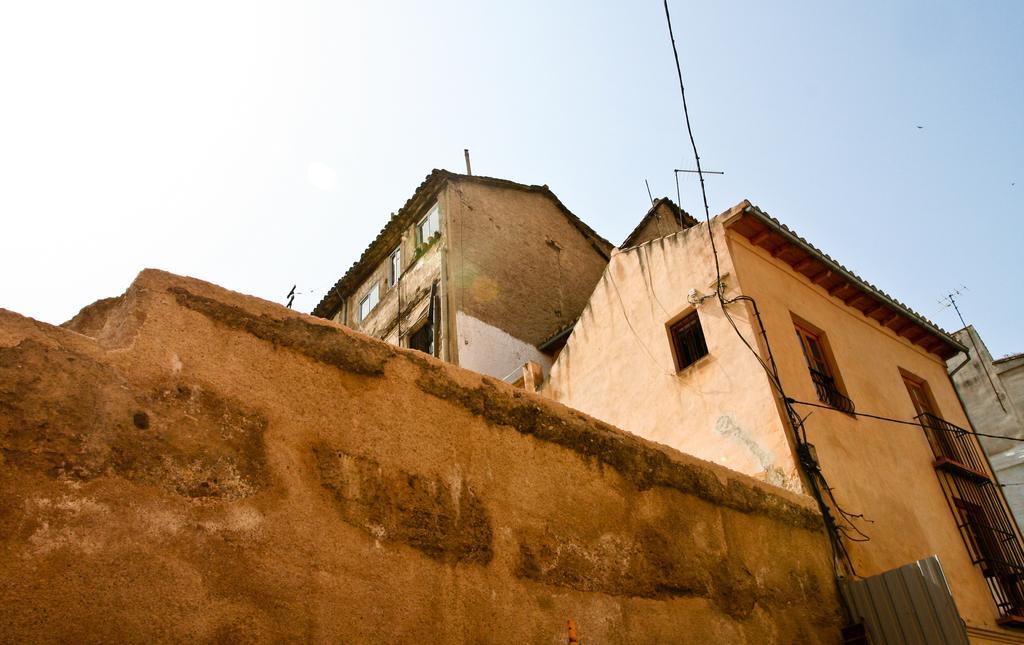In one or two sentences, can you explain what this image depicts? In this image we can see wall, buildings, and wires. In the background there is sky. 